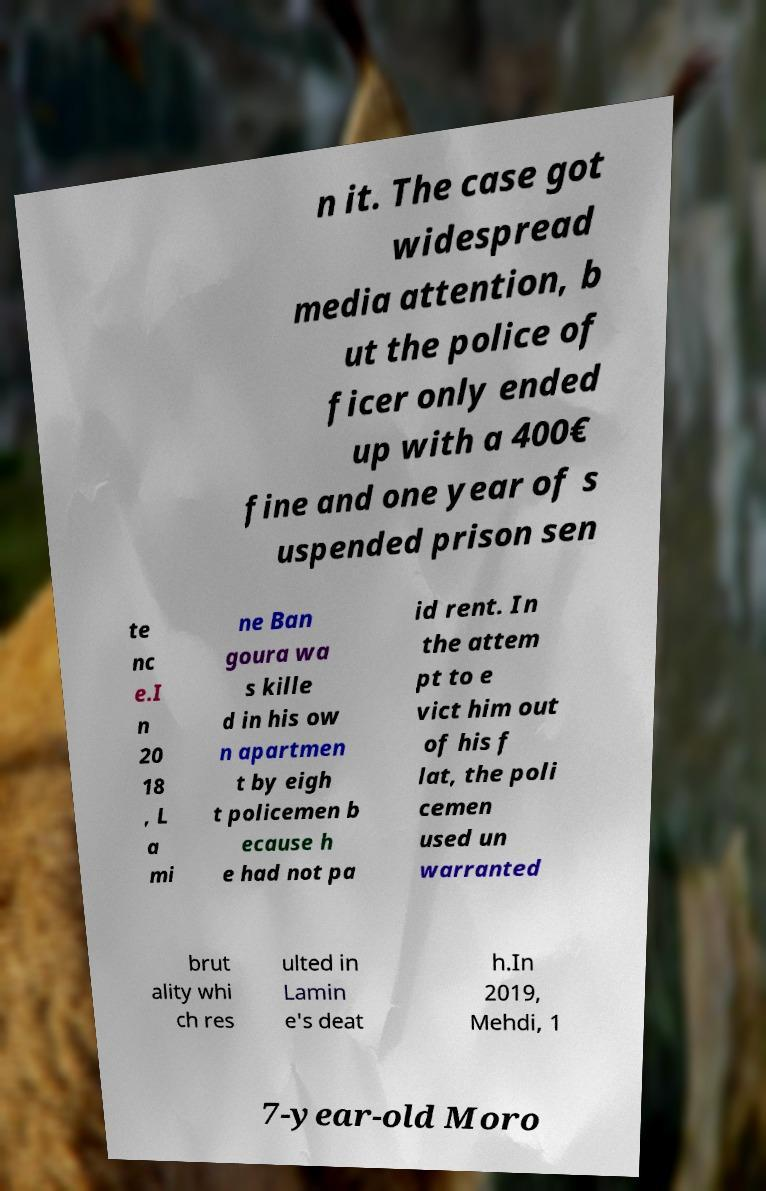There's text embedded in this image that I need extracted. Can you transcribe it verbatim? n it. The case got widespread media attention, b ut the police of ficer only ended up with a 400€ fine and one year of s uspended prison sen te nc e.I n 20 18 , L a mi ne Ban goura wa s kille d in his ow n apartmen t by eigh t policemen b ecause h e had not pa id rent. In the attem pt to e vict him out of his f lat, the poli cemen used un warranted brut ality whi ch res ulted in Lamin e's deat h.In 2019, Mehdi, 1 7-year-old Moro 